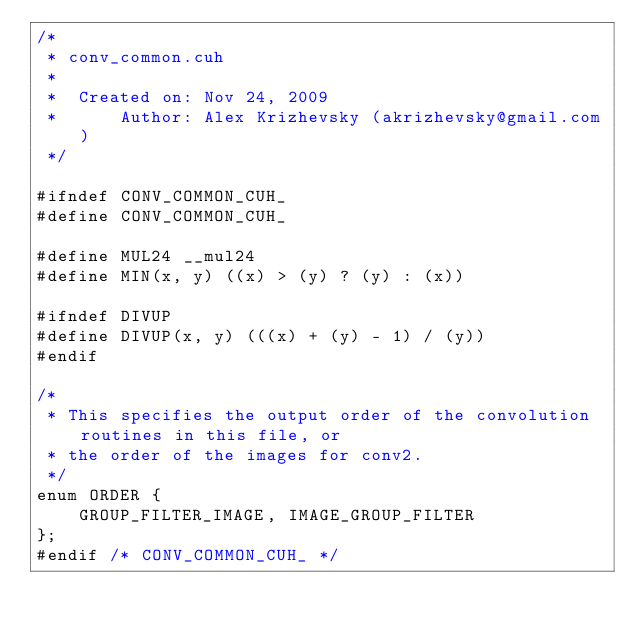Convert code to text. <code><loc_0><loc_0><loc_500><loc_500><_Cuda_>/*
 * conv_common.cuh
 *
 *  Created on: Nov 24, 2009
 *      Author: Alex Krizhevsky (akrizhevsky@gmail.com)
 */

#ifndef CONV_COMMON_CUH_
#define CONV_COMMON_CUH_

#define MUL24 __mul24
#define MIN(x, y) ((x) > (y) ? (y) : (x))

#ifndef DIVUP
#define DIVUP(x, y) (((x) + (y) - 1) / (y))
#endif

/*
 * This specifies the output order of the convolution routines in this file, or
 * the order of the images for conv2.
 */
enum ORDER {
    GROUP_FILTER_IMAGE, IMAGE_GROUP_FILTER
};
#endif /* CONV_COMMON_CUH_ */
</code> 